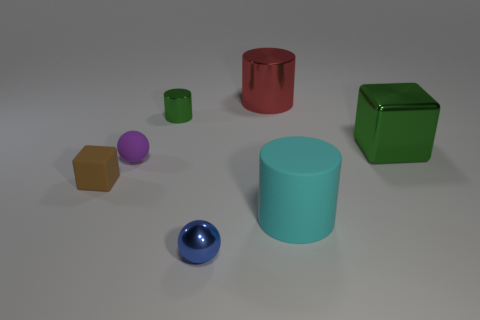Add 2 green metal cubes. How many objects exist? 9 Subtract all tiny cylinders. How many cylinders are left? 2 Subtract all red cylinders. How many cylinders are left? 2 Subtract 2 cylinders. How many cylinders are left? 1 Subtract 0 blue blocks. How many objects are left? 7 Subtract all spheres. How many objects are left? 5 Subtract all gray cubes. Subtract all green cylinders. How many cubes are left? 2 Subtract all red spheres. How many blue blocks are left? 0 Subtract all tiny blue objects. Subtract all brown things. How many objects are left? 5 Add 6 large cyan rubber things. How many large cyan rubber things are left? 7 